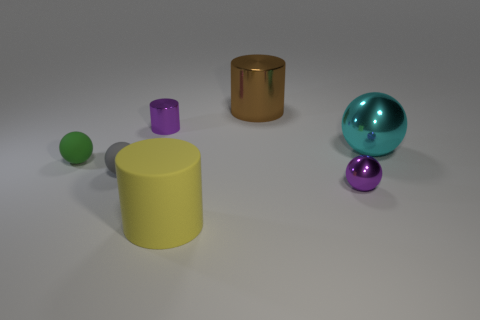Subtract all big matte cylinders. How many cylinders are left? 2 Add 2 big blue matte balls. How many objects exist? 9 Subtract all green spheres. How many spheres are left? 3 Subtract all cylinders. How many objects are left? 4 Subtract all gray rubber things. Subtract all purple objects. How many objects are left? 4 Add 2 cyan things. How many cyan things are left? 3 Add 5 big things. How many big things exist? 8 Subtract 1 green balls. How many objects are left? 6 Subtract 1 cylinders. How many cylinders are left? 2 Subtract all cyan spheres. Subtract all cyan cubes. How many spheres are left? 3 